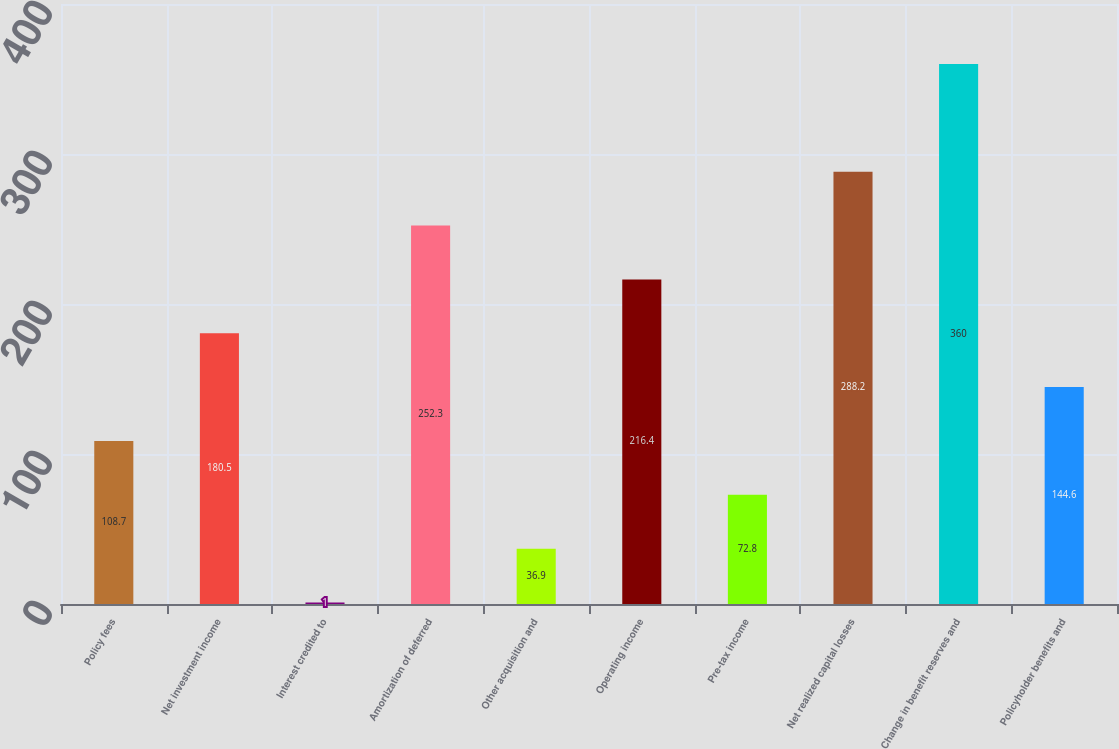Convert chart to OTSL. <chart><loc_0><loc_0><loc_500><loc_500><bar_chart><fcel>Policy fees<fcel>Net investment income<fcel>Interest credited to<fcel>Amortization of deferred<fcel>Other acquisition and<fcel>Operating income<fcel>Pre-tax income<fcel>Net realized capital losses<fcel>Change in benefit reserves and<fcel>Policyholder benefits and<nl><fcel>108.7<fcel>180.5<fcel>1<fcel>252.3<fcel>36.9<fcel>216.4<fcel>72.8<fcel>288.2<fcel>360<fcel>144.6<nl></chart> 